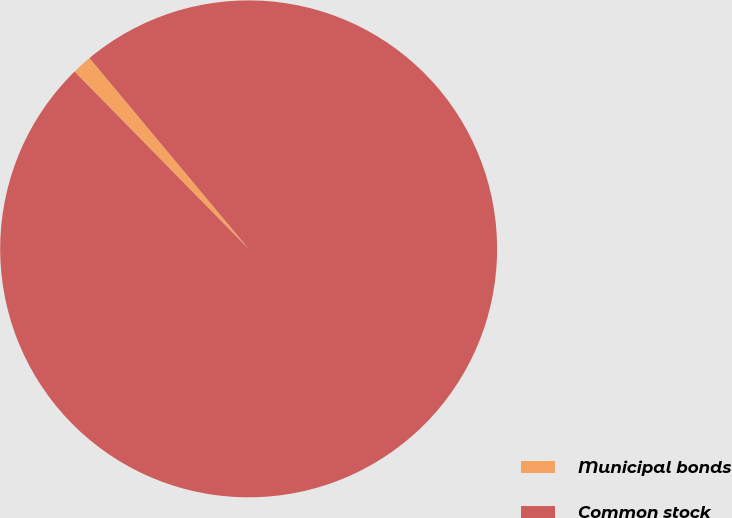Convert chart to OTSL. <chart><loc_0><loc_0><loc_500><loc_500><pie_chart><fcel>Municipal bonds<fcel>Common stock<nl><fcel>1.29%<fcel>98.71%<nl></chart> 